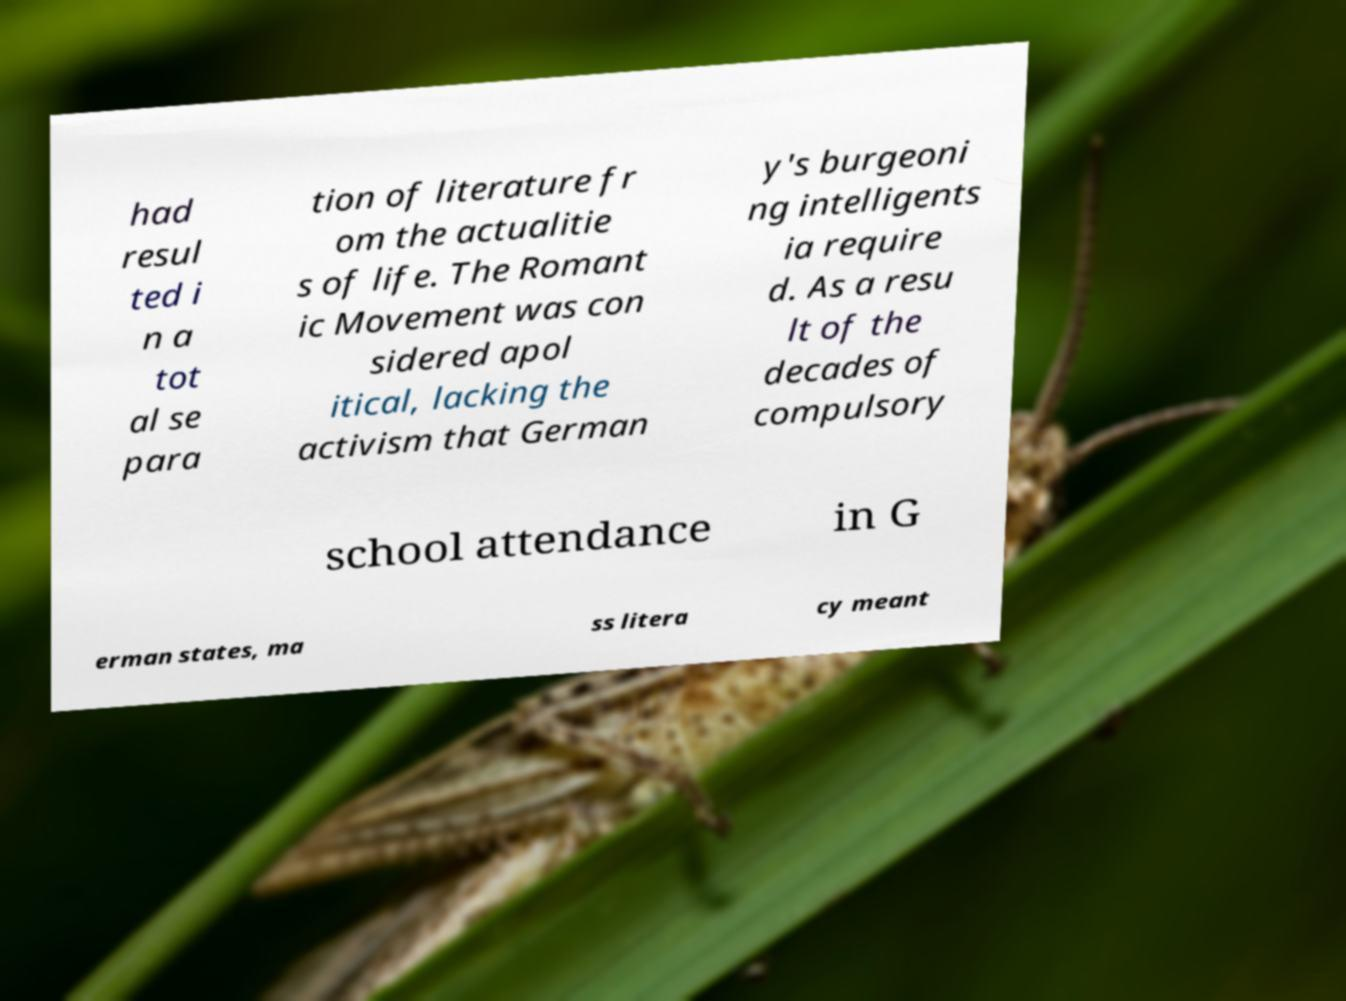Please identify and transcribe the text found in this image. had resul ted i n a tot al se para tion of literature fr om the actualitie s of life. The Romant ic Movement was con sidered apol itical, lacking the activism that German y's burgeoni ng intelligents ia require d. As a resu lt of the decades of compulsory school attendance in G erman states, ma ss litera cy meant 